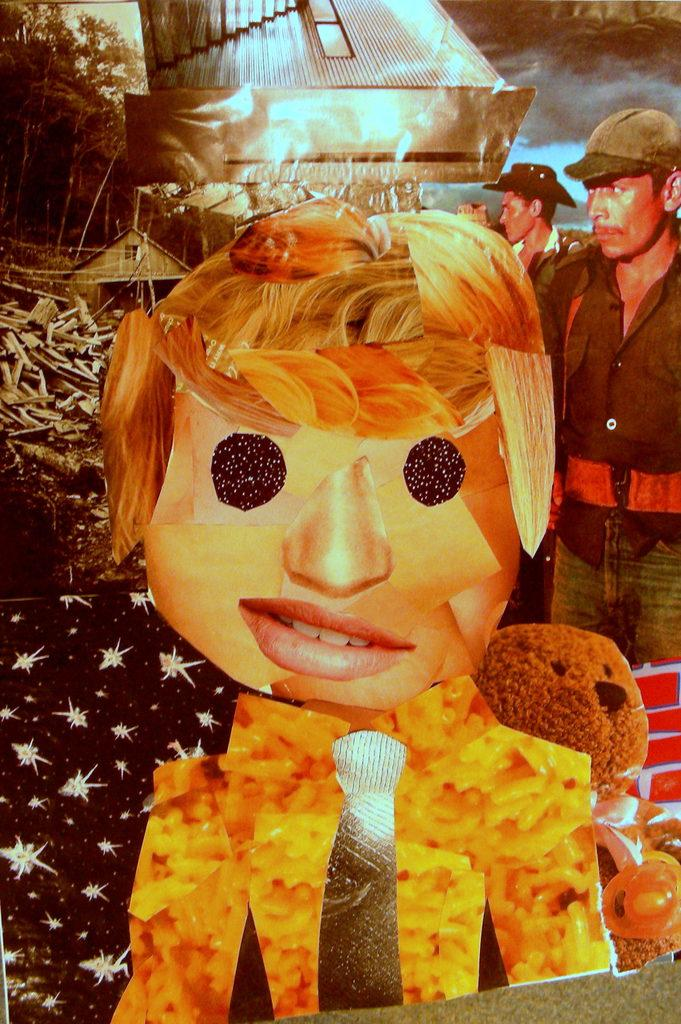What type of image is depicted on the poster in the image? There is a poster of people in the image. What other type of picture can be seen in the image? There is a cartoon picture of a person in the image. What kind of object is present in the image? There is a toy in the image. What type of natural vegetation is visible in the image? There are trees in the image. Can you describe any other objects in the image? There are other unspecified objects in the image. What degree of mint is present in the image? There is no mention of mint in the image, so it cannot be determined if any degree of mint is present. 